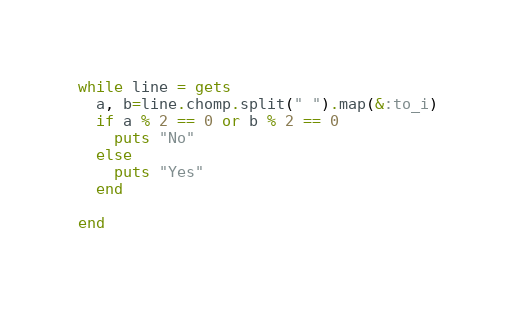Convert code to text. <code><loc_0><loc_0><loc_500><loc_500><_Ruby_>while line = gets
  a, b=line.chomp.split(" ").map(&:to_i)
  if a % 2 == 0 or b % 2 == 0
    puts "No"
  else
    puts "Yes"
  end
  
end</code> 